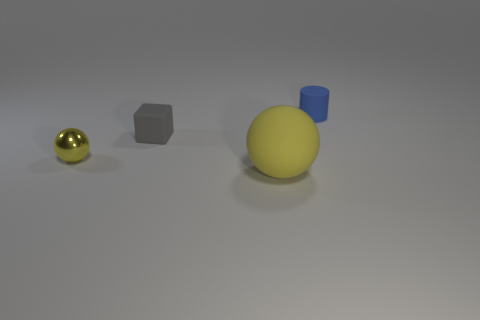Subtract all cyan cubes. Subtract all brown cylinders. How many cubes are left? 1 Add 4 tiny blue cylinders. How many objects exist? 8 Subtract all cylinders. How many objects are left? 3 Add 2 small gray cubes. How many small gray cubes exist? 3 Subtract 0 yellow cubes. How many objects are left? 4 Subtract all big balls. Subtract all brown blocks. How many objects are left? 3 Add 2 tiny cylinders. How many tiny cylinders are left? 3 